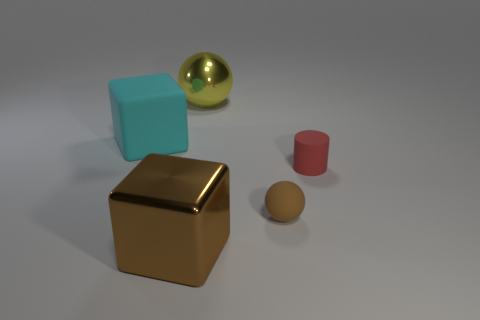There is a ball that is the same size as the matte cylinder; what material is it?
Your response must be concise. Rubber. Are there fewer objects that are on the right side of the yellow ball than objects that are to the left of the red object?
Provide a short and direct response. Yes. What shape is the object that is both behind the tiny brown matte thing and in front of the cyan thing?
Offer a very short reply. Cylinder. What number of big brown objects are the same shape as the red matte object?
Your response must be concise. 0. There is a ball that is the same material as the small cylinder; what size is it?
Your answer should be very brief. Small. Is the number of yellow metallic things greater than the number of small yellow things?
Offer a very short reply. Yes. What color is the matte object on the left side of the large yellow sphere?
Provide a succinct answer. Cyan. There is a matte object that is both on the left side of the tiny red cylinder and to the right of the yellow metal sphere; what is its size?
Ensure brevity in your answer.  Small. What number of green blocks are the same size as the red cylinder?
Your response must be concise. 0. There is a big brown object that is the same shape as the large cyan object; what is it made of?
Give a very brief answer. Metal. 